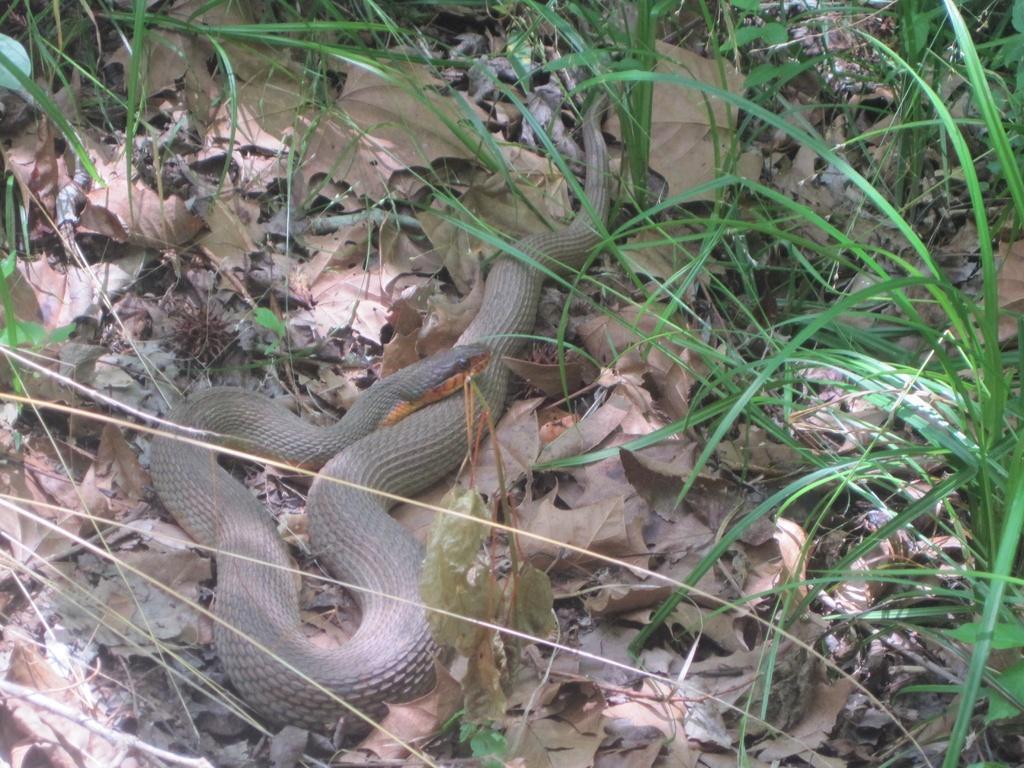How would you summarize this image in a sentence or two? In this picture I can see a snake, and there are leaves and grass. 